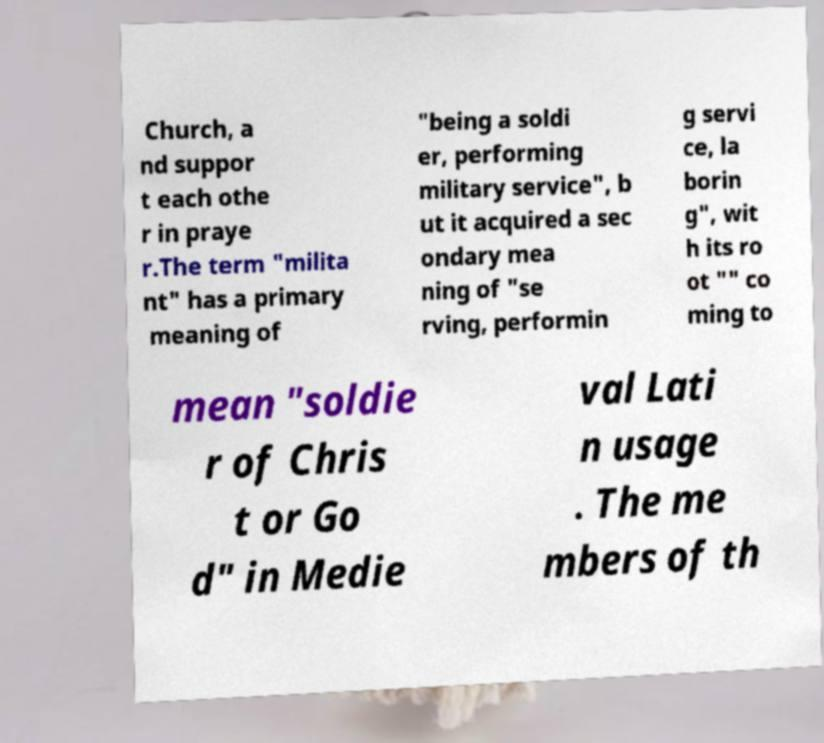What messages or text are displayed in this image? I need them in a readable, typed format. Church, a nd suppor t each othe r in praye r.The term "milita nt" has a primary meaning of "being a soldi er, performing military service", b ut it acquired a sec ondary mea ning of "se rving, performin g servi ce, la borin g", wit h its ro ot "" co ming to mean "soldie r of Chris t or Go d" in Medie val Lati n usage . The me mbers of th 